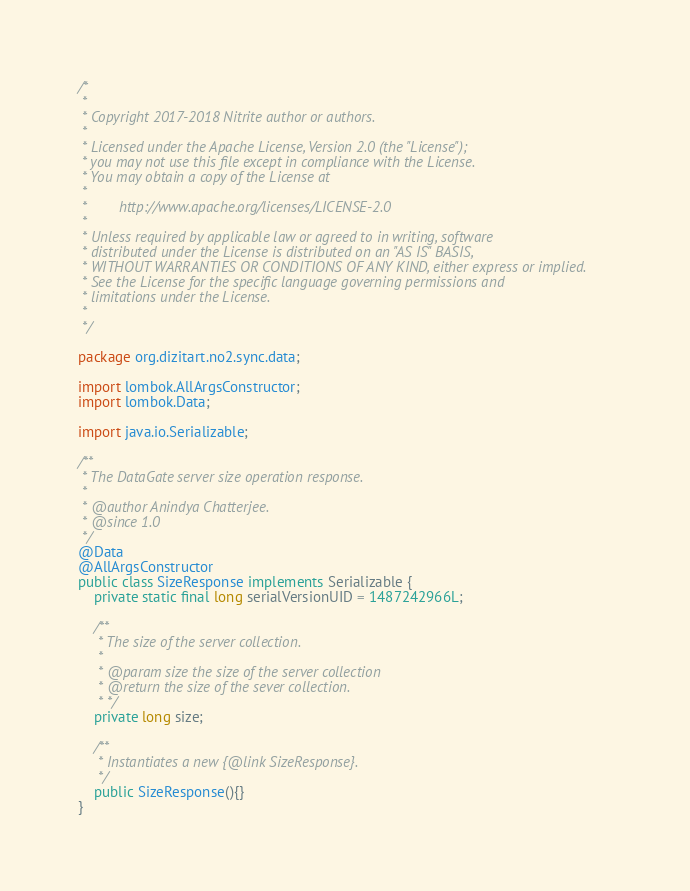Convert code to text. <code><loc_0><loc_0><loc_500><loc_500><_Java_>/*
 *
 * Copyright 2017-2018 Nitrite author or authors.
 *
 * Licensed under the Apache License, Version 2.0 (the "License");
 * you may not use this file except in compliance with the License.
 * You may obtain a copy of the License at
 *
 *        http://www.apache.org/licenses/LICENSE-2.0
 *
 * Unless required by applicable law or agreed to in writing, software
 * distributed under the License is distributed on an "AS IS" BASIS,
 * WITHOUT WARRANTIES OR CONDITIONS OF ANY KIND, either express or implied.
 * See the License for the specific language governing permissions and
 * limitations under the License.
 *
 */

package org.dizitart.no2.sync.data;

import lombok.AllArgsConstructor;
import lombok.Data;

import java.io.Serializable;

/**
 * The DataGate server size operation response.
 *
 * @author Anindya Chatterjee.
 * @since 1.0
 */
@Data
@AllArgsConstructor
public class SizeResponse implements Serializable {
    private static final long serialVersionUID = 1487242966L;

    /**
     * The size of the server collection.
     *
     * @param size the size of the server collection
     * @return the size of the sever collection.
     * */
    private long size;

    /**
     * Instantiates a new {@link SizeResponse}.
     */
    public SizeResponse(){}
}
</code> 